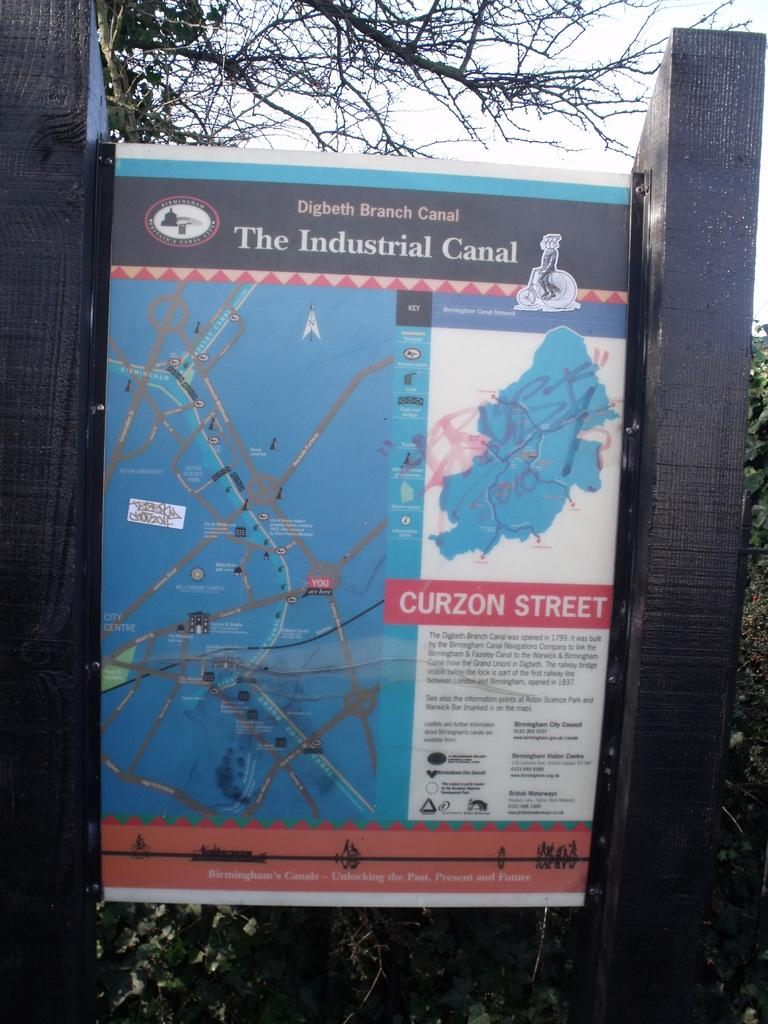What is the main object in the image? There is a map on poles in the image. What type of natural environment is visible in the image? There are many trees visible in the image. What type of music is the band playing in the image? There is no band present in the image, so it is not possible to determine what type of music they might be playing. What is the cause of the trees in the image? The cause of the trees in the image is not mentioned, as the image only shows the trees and the map on poles. 